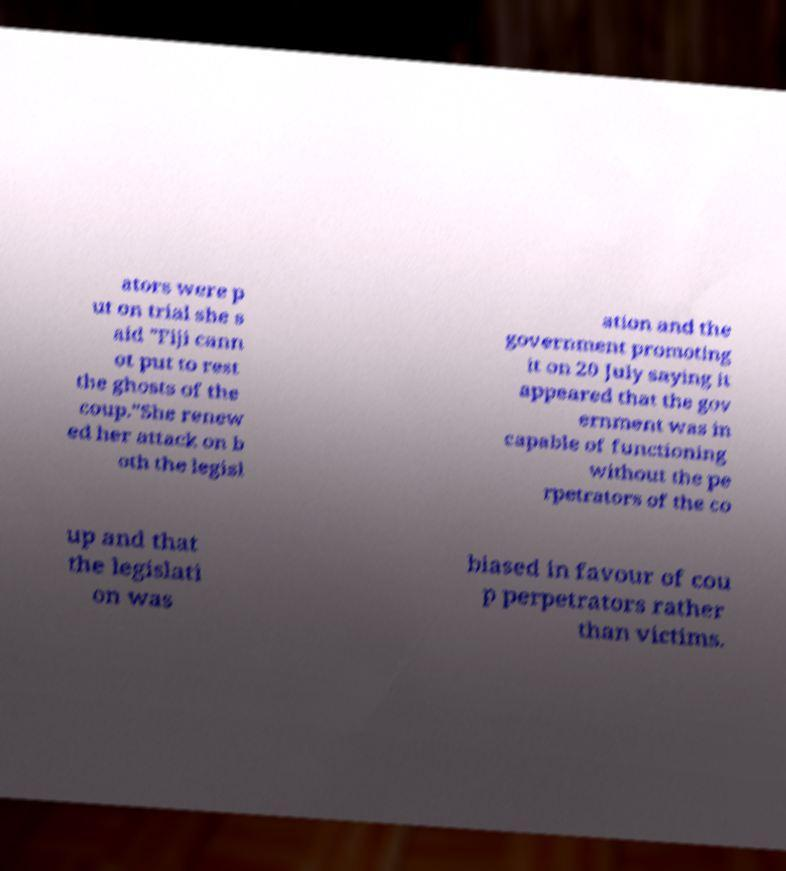Could you extract and type out the text from this image? ators were p ut on trial she s aid "Fiji cann ot put to rest the ghosts of the coup."She renew ed her attack on b oth the legisl ation and the government promoting it on 20 July saying it appeared that the gov ernment was in capable of functioning without the pe rpetrators of the co up and that the legislati on was biased in favour of cou p perpetrators rather than victims. 